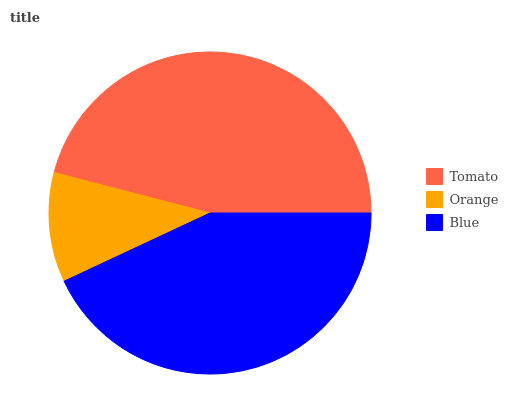Is Orange the minimum?
Answer yes or no. Yes. Is Tomato the maximum?
Answer yes or no. Yes. Is Blue the minimum?
Answer yes or no. No. Is Blue the maximum?
Answer yes or no. No. Is Blue greater than Orange?
Answer yes or no. Yes. Is Orange less than Blue?
Answer yes or no. Yes. Is Orange greater than Blue?
Answer yes or no. No. Is Blue less than Orange?
Answer yes or no. No. Is Blue the high median?
Answer yes or no. Yes. Is Blue the low median?
Answer yes or no. Yes. Is Orange the high median?
Answer yes or no. No. Is Tomato the low median?
Answer yes or no. No. 